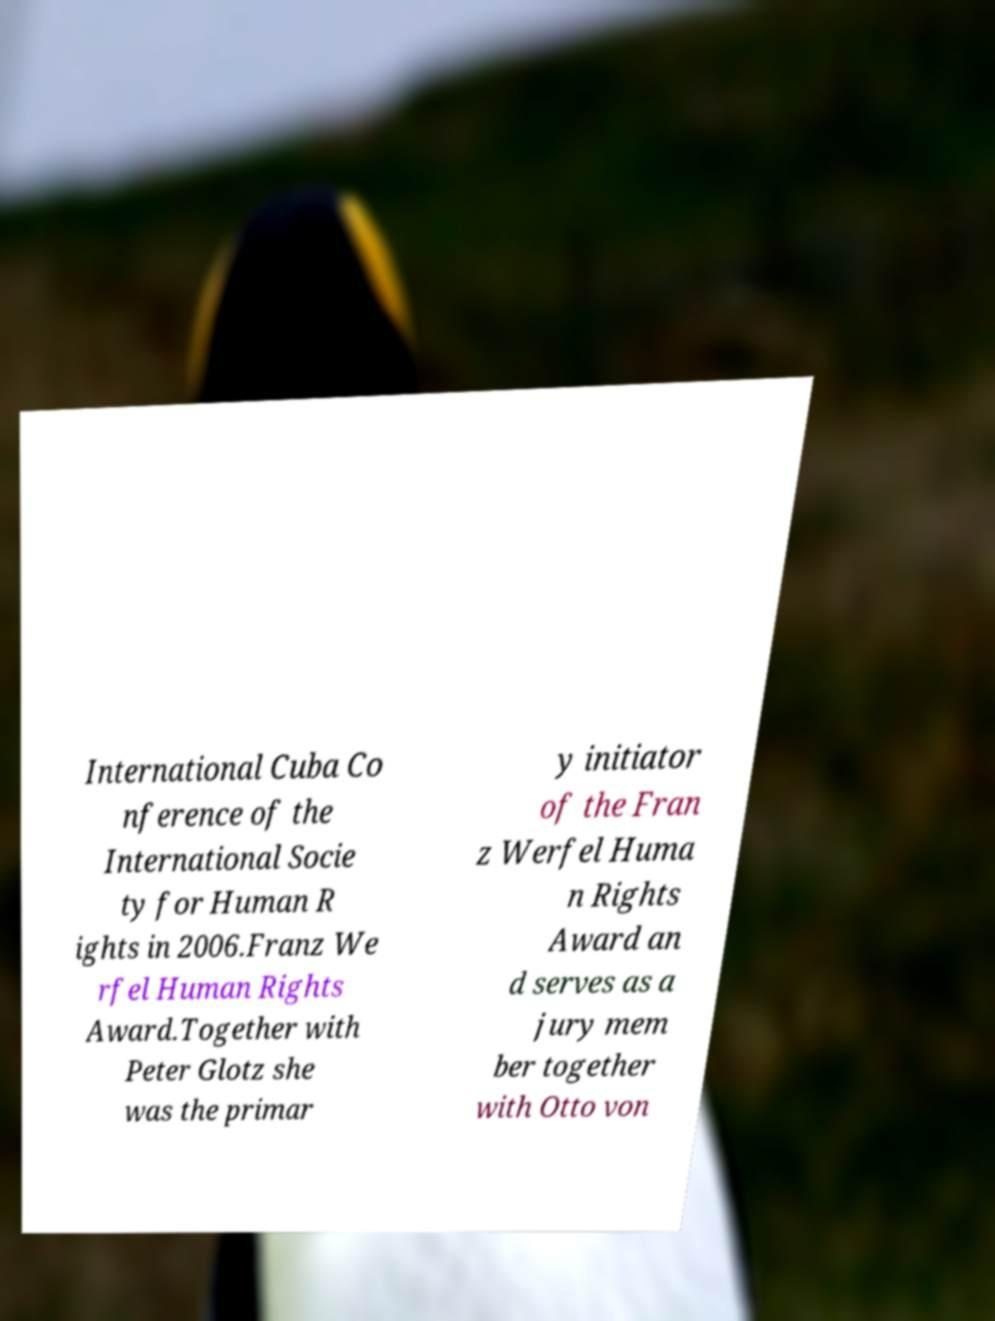What messages or text are displayed in this image? I need them in a readable, typed format. International Cuba Co nference of the International Socie ty for Human R ights in 2006.Franz We rfel Human Rights Award.Together with Peter Glotz she was the primar y initiator of the Fran z Werfel Huma n Rights Award an d serves as a jury mem ber together with Otto von 